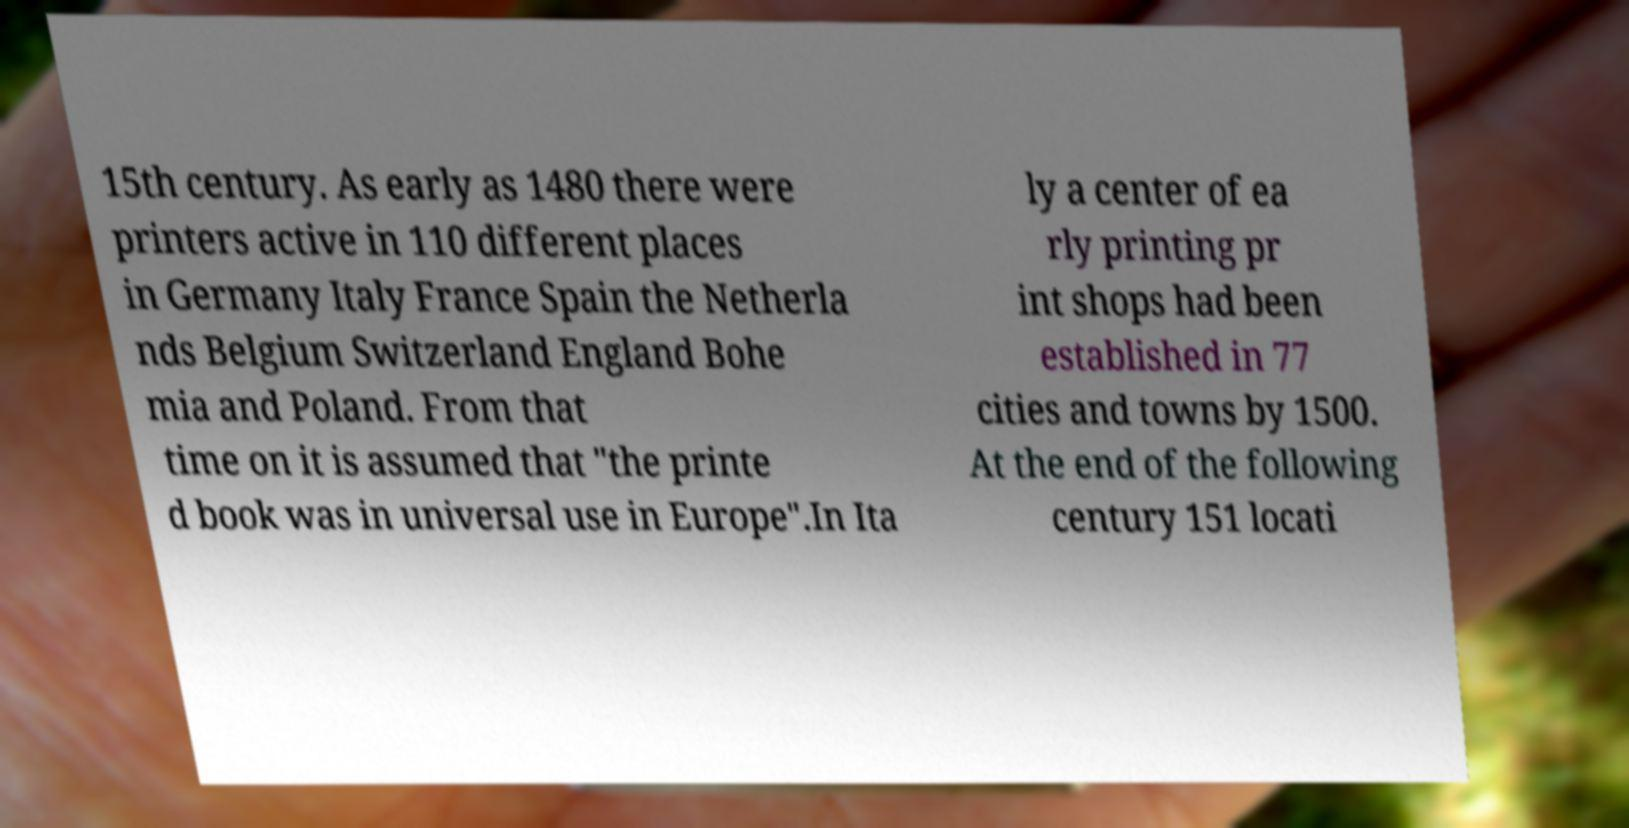What messages or text are displayed in this image? I need them in a readable, typed format. 15th century. As early as 1480 there were printers active in 110 different places in Germany Italy France Spain the Netherla nds Belgium Switzerland England Bohe mia and Poland. From that time on it is assumed that "the printe d book was in universal use in Europe".In Ita ly a center of ea rly printing pr int shops had been established in 77 cities and towns by 1500. At the end of the following century 151 locati 